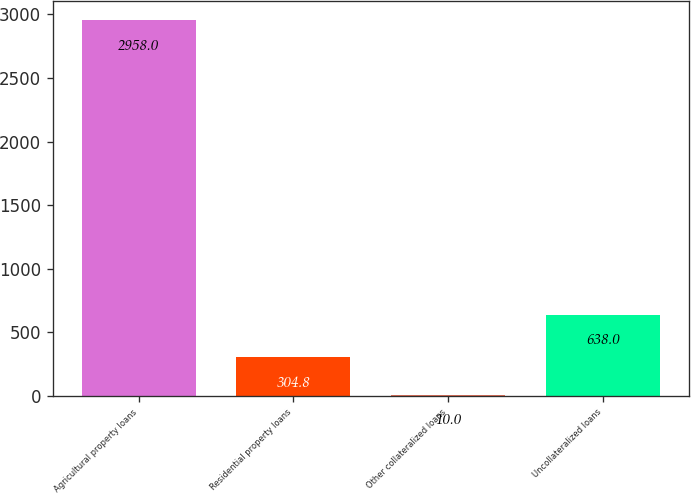<chart> <loc_0><loc_0><loc_500><loc_500><bar_chart><fcel>Agricultural property loans<fcel>Residential property loans<fcel>Other collateralized loans<fcel>Uncollateralized loans<nl><fcel>2958<fcel>304.8<fcel>10<fcel>638<nl></chart> 